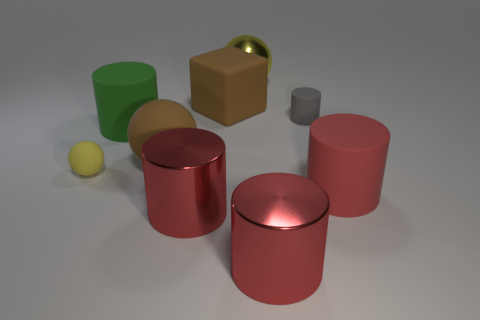Subtract all gray cubes. How many red cylinders are left? 3 Subtract all gray cylinders. How many cylinders are left? 4 Subtract all large green cylinders. How many cylinders are left? 4 Subtract all purple cylinders. Subtract all yellow blocks. How many cylinders are left? 5 Subtract all blocks. How many objects are left? 8 Add 6 small gray things. How many small gray things are left? 7 Add 9 small gray matte objects. How many small gray matte objects exist? 10 Subtract 0 brown cylinders. How many objects are left? 9 Subtract all brown objects. Subtract all green cylinders. How many objects are left? 6 